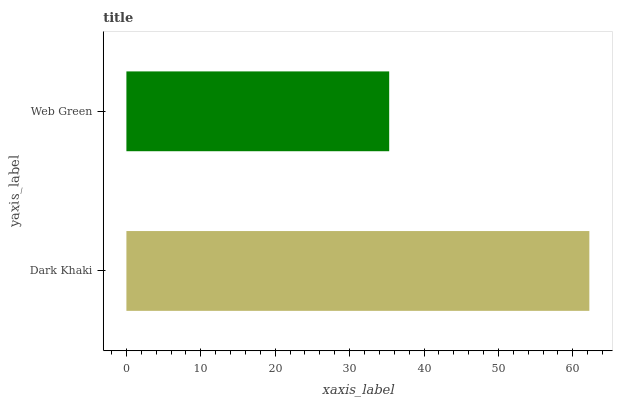Is Web Green the minimum?
Answer yes or no. Yes. Is Dark Khaki the maximum?
Answer yes or no. Yes. Is Web Green the maximum?
Answer yes or no. No. Is Dark Khaki greater than Web Green?
Answer yes or no. Yes. Is Web Green less than Dark Khaki?
Answer yes or no. Yes. Is Web Green greater than Dark Khaki?
Answer yes or no. No. Is Dark Khaki less than Web Green?
Answer yes or no. No. Is Dark Khaki the high median?
Answer yes or no. Yes. Is Web Green the low median?
Answer yes or no. Yes. Is Web Green the high median?
Answer yes or no. No. Is Dark Khaki the low median?
Answer yes or no. No. 